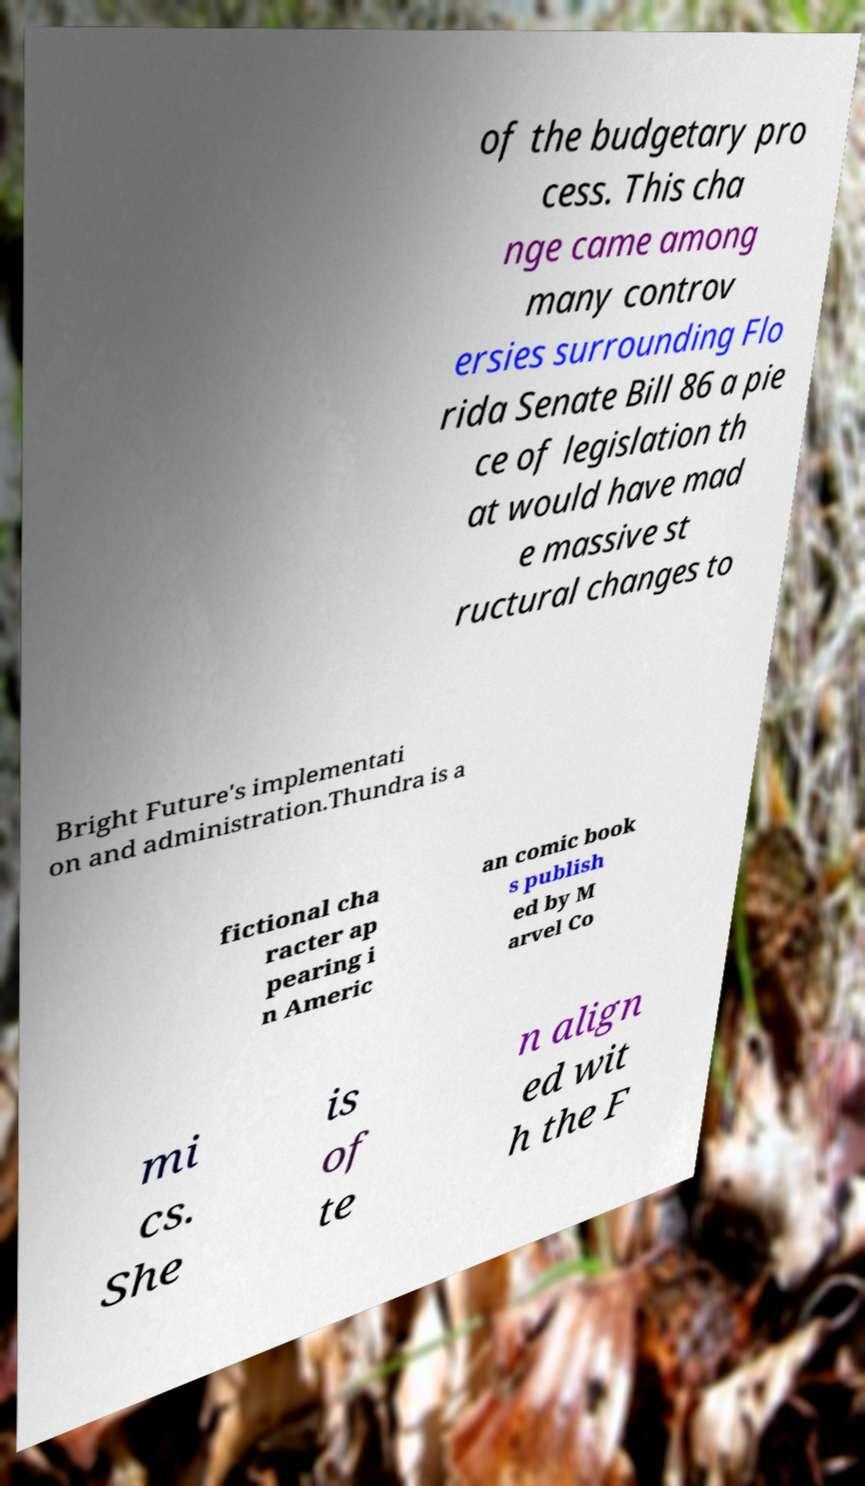There's text embedded in this image that I need extracted. Can you transcribe it verbatim? of the budgetary pro cess. This cha nge came among many controv ersies surrounding Flo rida Senate Bill 86 a pie ce of legislation th at would have mad e massive st ructural changes to Bright Future's implementati on and administration.Thundra is a fictional cha racter ap pearing i n Americ an comic book s publish ed by M arvel Co mi cs. She is of te n align ed wit h the F 